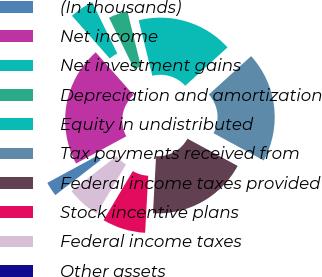Convert chart to OTSL. <chart><loc_0><loc_0><loc_500><loc_500><pie_chart><fcel>(In thousands)<fcel>Net income<fcel>Net investment gains<fcel>Depreciation and amortization<fcel>Equity in undistributed<fcel>Tax payments received from<fcel>Federal income taxes provided<fcel>Stock incentive plans<fcel>Federal income taxes<fcel>Other assets<nl><fcel>2.57%<fcel>21.36%<fcel>4.28%<fcel>3.42%<fcel>17.09%<fcel>19.65%<fcel>17.94%<fcel>7.69%<fcel>5.98%<fcel>0.0%<nl></chart> 